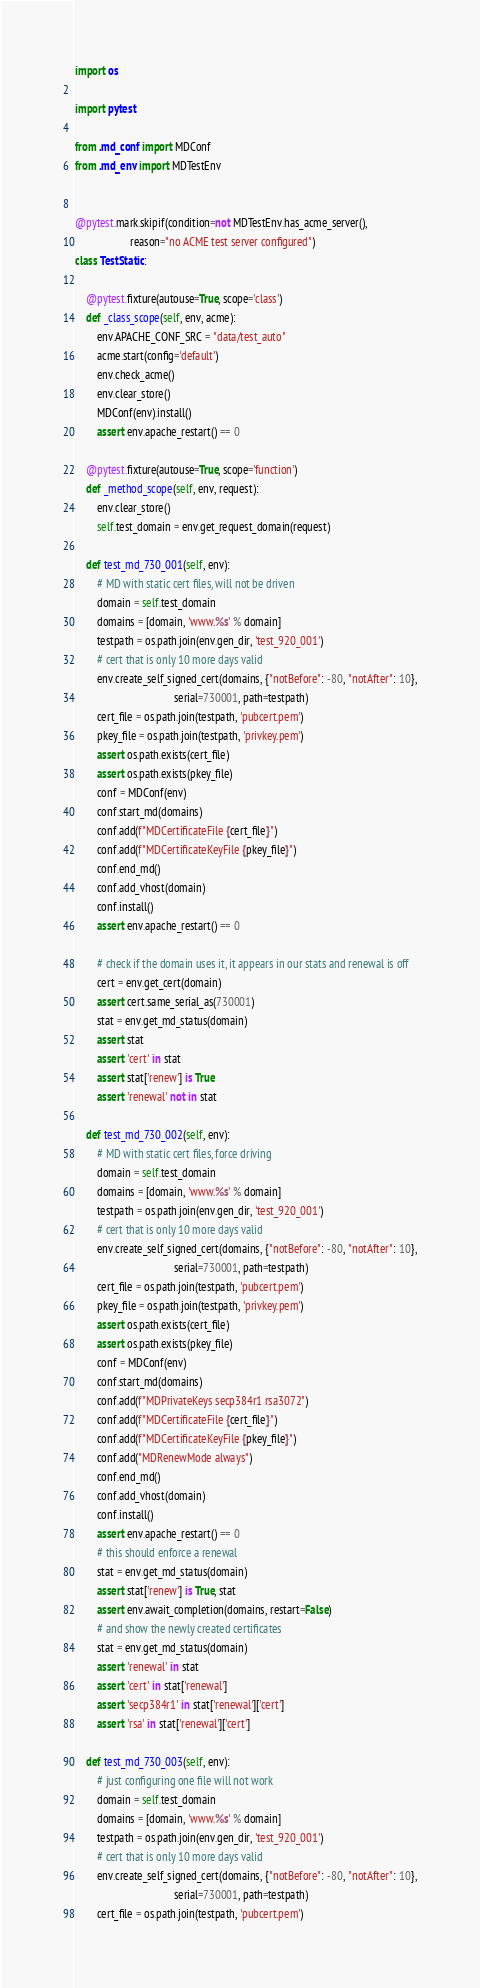Convert code to text. <code><loc_0><loc_0><loc_500><loc_500><_Python_>import os

import pytest

from .md_conf import MDConf
from .md_env import MDTestEnv


@pytest.mark.skipif(condition=not MDTestEnv.has_acme_server(),
                    reason="no ACME test server configured")
class TestStatic:

    @pytest.fixture(autouse=True, scope='class')
    def _class_scope(self, env, acme):
        env.APACHE_CONF_SRC = "data/test_auto"
        acme.start(config='default')
        env.check_acme()
        env.clear_store()
        MDConf(env).install()
        assert env.apache_restart() == 0

    @pytest.fixture(autouse=True, scope='function')
    def _method_scope(self, env, request):
        env.clear_store()
        self.test_domain = env.get_request_domain(request)

    def test_md_730_001(self, env):
        # MD with static cert files, will not be driven
        domain = self.test_domain
        domains = [domain, 'www.%s' % domain]
        testpath = os.path.join(env.gen_dir, 'test_920_001')
        # cert that is only 10 more days valid
        env.create_self_signed_cert(domains, {"notBefore": -80, "notAfter": 10},
                                    serial=730001, path=testpath)
        cert_file = os.path.join(testpath, 'pubcert.pem')
        pkey_file = os.path.join(testpath, 'privkey.pem')
        assert os.path.exists(cert_file)
        assert os.path.exists(pkey_file)
        conf = MDConf(env)
        conf.start_md(domains)
        conf.add(f"MDCertificateFile {cert_file}")
        conf.add(f"MDCertificateKeyFile {pkey_file}")
        conf.end_md()
        conf.add_vhost(domain)
        conf.install()
        assert env.apache_restart() == 0
        
        # check if the domain uses it, it appears in our stats and renewal is off
        cert = env.get_cert(domain)
        assert cert.same_serial_as(730001)
        stat = env.get_md_status(domain)
        assert stat
        assert 'cert' in stat
        assert stat['renew'] is True
        assert 'renewal' not in stat

    def test_md_730_002(self, env):
        # MD with static cert files, force driving
        domain = self.test_domain
        domains = [domain, 'www.%s' % domain]
        testpath = os.path.join(env.gen_dir, 'test_920_001')
        # cert that is only 10 more days valid
        env.create_self_signed_cert(domains, {"notBefore": -80, "notAfter": 10},
                                    serial=730001, path=testpath)
        cert_file = os.path.join(testpath, 'pubcert.pem')
        pkey_file = os.path.join(testpath, 'privkey.pem')
        assert os.path.exists(cert_file)
        assert os.path.exists(pkey_file)
        conf = MDConf(env)
        conf.start_md(domains)
        conf.add(f"MDPrivateKeys secp384r1 rsa3072")
        conf.add(f"MDCertificateFile {cert_file}")
        conf.add(f"MDCertificateKeyFile {pkey_file}")
        conf.add("MDRenewMode always")
        conf.end_md()
        conf.add_vhost(domain)
        conf.install()
        assert env.apache_restart() == 0
        # this should enforce a renewal
        stat = env.get_md_status(domain)
        assert stat['renew'] is True, stat
        assert env.await_completion(domains, restart=False)
        # and show the newly created certificates
        stat = env.get_md_status(domain)
        assert 'renewal' in stat
        assert 'cert' in stat['renewal']
        assert 'secp384r1' in stat['renewal']['cert']
        assert 'rsa' in stat['renewal']['cert']

    def test_md_730_003(self, env):
        # just configuring one file will not work
        domain = self.test_domain
        domains = [domain, 'www.%s' % domain]
        testpath = os.path.join(env.gen_dir, 'test_920_001')
        # cert that is only 10 more days valid
        env.create_self_signed_cert(domains, {"notBefore": -80, "notAfter": 10},
                                    serial=730001, path=testpath)
        cert_file = os.path.join(testpath, 'pubcert.pem')</code> 